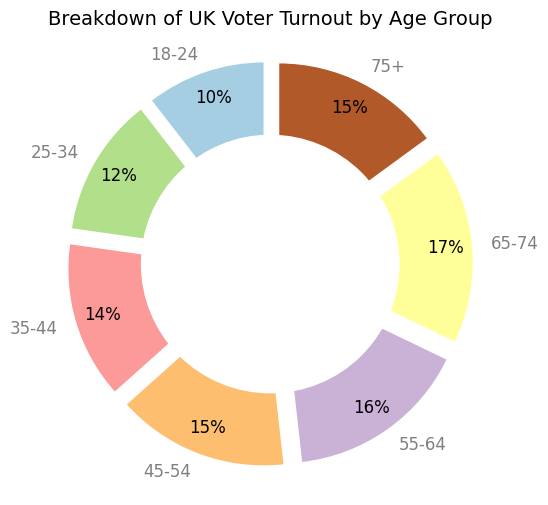What age group has the highest voter turnout percentage? The ring chart shows different voter turnout percentages for each age group. From the chart, the 65-74 age group has the highest percentage.
Answer: 65-74 Which age group has the lowest voter turnout percentage? The ring chart shows percentages for each age group, and the 18-24 age group has the lowest voter turnout percentage.
Answer: 18-24 What is the difference in voter turnout percentage between the 25-34 and 65-74 age groups? According to the chart, the 25-34 age group has a turnout of 55%, and the 65-74 age group has a turnout of 77%. The difference is 77% - 55% = 22%.
Answer: 22% Is the voter turnout percentage for the 75+ age group higher or lower than the average turnout percentage of the 18-24 and 25-34 age groups? The average turnout percentage of the 18-24 and 25-34 age groups is (47% + 55%) / 2 = 51%. The 75+ age group has a turnout of 67%. 67% is higher than 51%.
Answer: Higher How many age groups have voter turnout percentages above 60%? The chart shows the percentages for each age group. Groups 35-44, 45-54, 55-64, 65-74, and 75+ have percentages above 60%. There are five such age groups.
Answer: 5 What is the voter turnout percentage for the 35-44 age group, and how does it compare to the 45-54 age group? The turnout percentage for the 35-44 age group is 62%, while for the 45-54 age group, it is 68%. 62% is less than 68%.
Answer: 62%, less Which colour represents the 18-24 age group in the chart? In the ring chart, each age group is represented by a different color. The color of the 18-24 age group can be determined from the plot. This group is represented by the first segment, which is likely to be the first color in the selected color palette.
Answer: (Color) What is the sum of the voter turnout percentages for the age groups 45-54 and 55-64? The turnout percentage for the 45-54 age group is 68%, and for the 55-64 age group, it is 72%. Summing these values gives 68% + 72% = 140%.
Answer: 140% If the voter turnout percentages for the 18-24 and 75+ age groups were to switch, which age group would then have the lowest voter turnout percentage? Initially, the 18-24 age group has the lowest at 47%. If switched with the 75+ group, which has 67%, then the 75+ group would have 47%, making it the lowest.
Answer: 75+ Is there any age group with a voter turnout percentage within 1% of 70%? According to the chart, the 55-64 age group has a turnout of 72%, which is within 2% of 70%, but none are within 1%.
Answer: No 